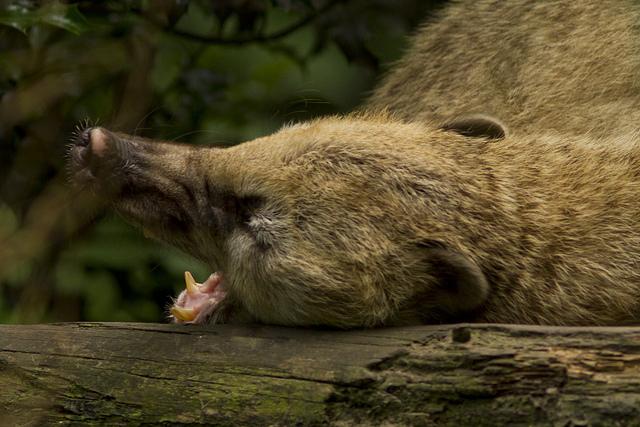What color is the fur?
Short answer required. Brown. Is the bear standing?
Concise answer only. No. How many teeth are showing on the bear?
Short answer required. 2. How many bears are there?
Answer briefly. 1. What kind of animal is this?
Write a very short answer. Bear. What color bear is this?
Keep it brief. Brown. What kind of animal is laying down?
Keep it brief. Bear. 